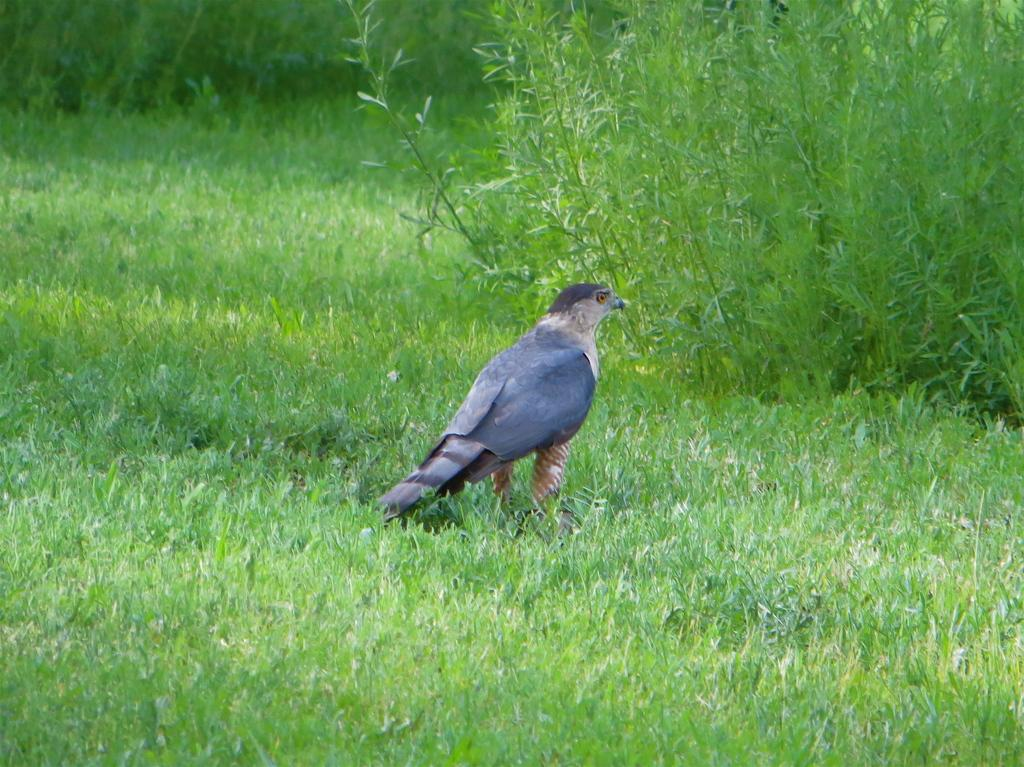What type of animal is in the image? There is a bird in the image. Where is the bird located? The bird is standing on the ground. What is the color or appearance of the ground? The ground appears to be green or covered in greenery. What can be seen in the right corner of the image? There are plants in the right corner of the image. What time of day is it in the image, and is there a group of people present? The time of day is not mentioned in the image, and there is no group of people present. 